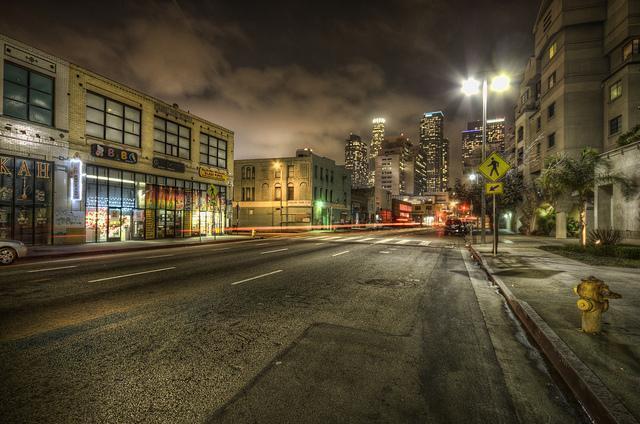What animal would you be most unlikely to see in this setting?
Choose the right answer and clarify with the format: 'Answer: answer
Rationale: rationale.'
Options: Tiger, dog, horse, cat. Answer: tiger.
Rationale: Tigers are not in urban areas. 